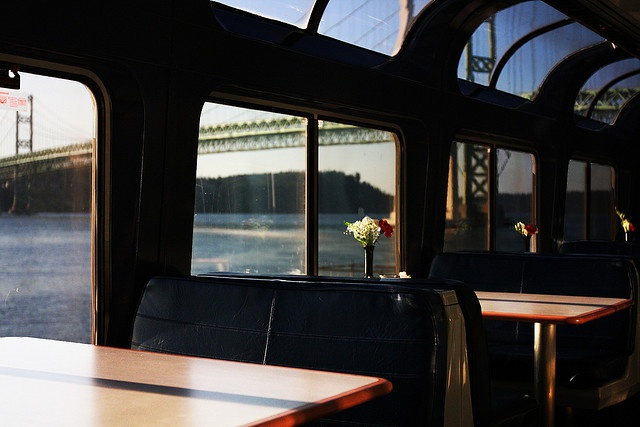Describe the objects in this image and their specific colors. I can see dining table in black, white, and tan tones, dining table in black, maroon, and tan tones, chair in black tones, vase in black, gray, lightyellow, and khaki tones, and vase in black, gray, brown, and tan tones in this image. 